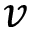<formula> <loc_0><loc_0><loc_500><loc_500>v</formula> 